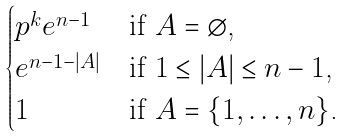<formula> <loc_0><loc_0><loc_500><loc_500>\begin{cases} p ^ { k } e ^ { n - 1 } & \text {if $A = \emptyset$,} \\ e ^ { n - 1 - | A | } & \text {if $1\leq |A|\leq n-1$,} \\ 1 & \text {if $A =  \{1,\dots,n\}$.} \end{cases}</formula> 